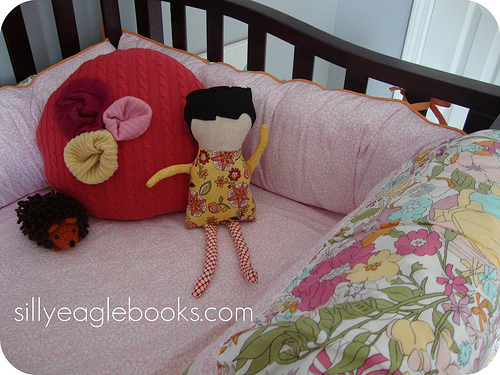<image>
Is there a toy on the sofa? Yes. Looking at the image, I can see the toy is positioned on top of the sofa, with the sofa providing support. Is the doll on the cushion? Yes. Looking at the image, I can see the doll is positioned on top of the cushion, with the cushion providing support. Where is the toy in relation to the bed? Is it behind the bed? No. The toy is not behind the bed. From this viewpoint, the toy appears to be positioned elsewhere in the scene. 